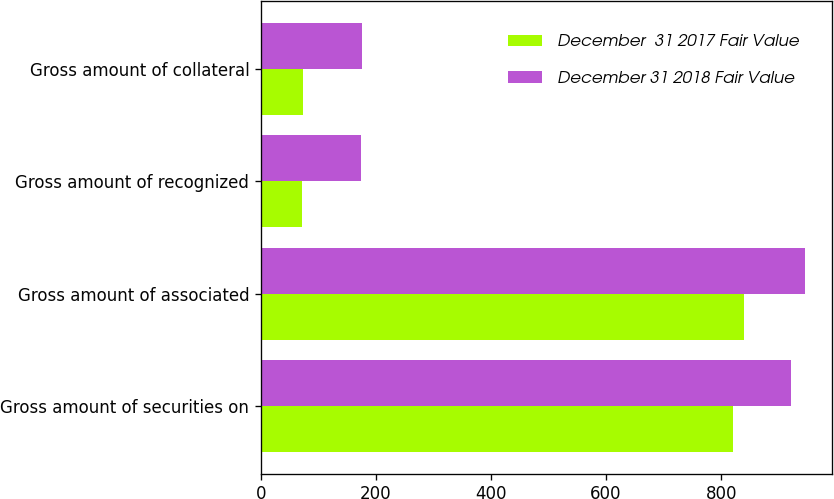Convert chart to OTSL. <chart><loc_0><loc_0><loc_500><loc_500><stacked_bar_chart><ecel><fcel>Gross amount of securities on<fcel>Gross amount of associated<fcel>Gross amount of recognized<fcel>Gross amount of collateral<nl><fcel>December  31 2017 Fair Value<fcel>820<fcel>840<fcel>72<fcel>73<nl><fcel>December 31 2018 Fair Value<fcel>922<fcel>945<fcel>174<fcel>176<nl></chart> 